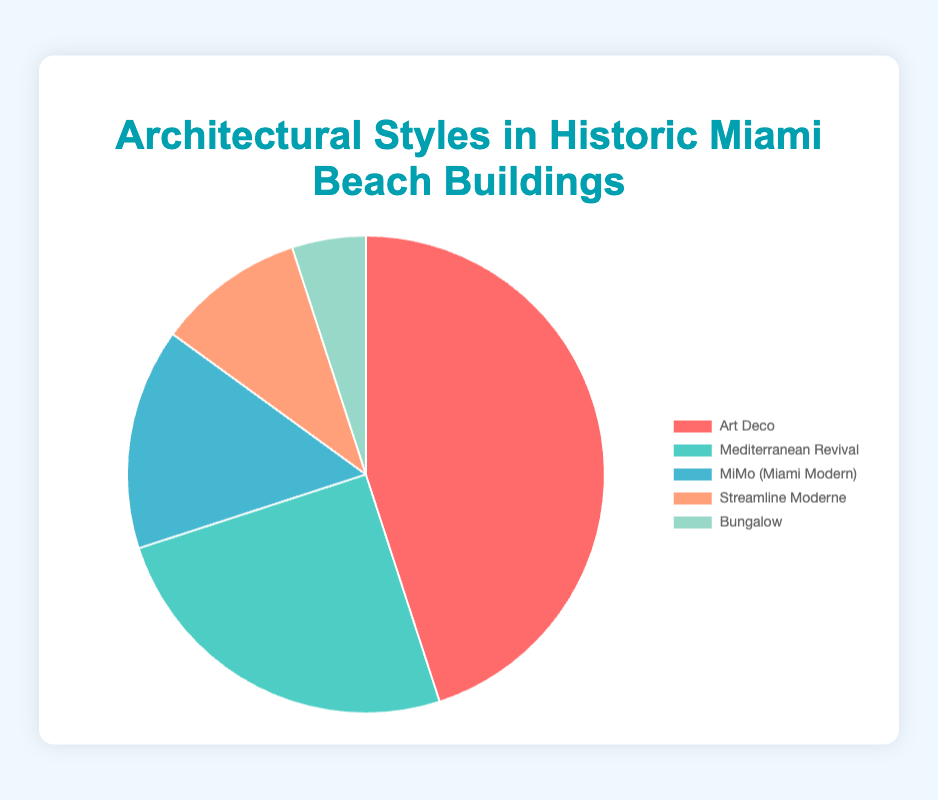What's the most prevalent architectural style among historic Miami Beach buildings? The pie chart shows different architectural styles and their proportions. The largest segment is "Art Deco," which comprises 45% of buildings.
Answer: Art Deco Which architectural style is represented in blue on the pie chart and what percentage does it hold? Looking at the colors in the pie chart, the "MiMo (Miami Modern)" segment is blue. It holds 15%.
Answer: MiMo (Miami Modern) - 15% How much larger is the percentage of Art Deco compared to Bungalow buildings? Art Deco is 45% and Bungalow is 5%. Subtracting these gives 45 - 5 = 40%.
Answer: 40% What is the combined percentage of Mediterranean Revival and Streamline Moderne styles? Mediterranean Revival holds 25% and Streamline Moderne holds 10%. Adding these gives 25 + 10 = 35%.
Answer: 35% How many times larger is the proportion of MiMo compared to Bungalow buildings? MiMo is 15% and Bungalow is 5%. Dividing these percentages gives 15 / 5 = 3 times.
Answer: 3 times Which architectural style holds the smallest percentage of buildings? The pie chart shows the segments and their sizes. The smallest segment is "Bungalow," which holds 5%.
Answer: Bungalow - 5% Is the percentage of Art Deco buildings greater than the combination of MiMo and Streamline Moderne? Art Deco is 45%, MiMo is 15%, and Streamline Moderne is 10%. Combining MiMo and Streamline Moderne gives 15 + 10 = 25%. Comparing 45% and 25%, Art Deco is greater.
Answer: Yes What percentage of the buildings is not Art Deco? Art Deco represents 45%. The total is 100%. Subtracting Art Deco's share gives 100 - 45 = 55%.
Answer: 55% If a new architectural style is to be added representing 10% of the buildings, what would be the new percentage of Mediterranean Revival buildings? Mediterranean Revival is currently 25%. Adding a new style means we need to calculate percentages from 90% (since we'd subtract 10% for the new style). New proportion: (25 / 90) * 100 = ~27.78%.
Answer: ~27.78% Which segment in the pie chart represents the second most common architectural style and what is its color? The two largest segments are Art Deco (45%) and Mediterranean Revival (25%). The second largest, Mediterranean Revival, is represented in green.
Answer: Mediterranean Revival - green 